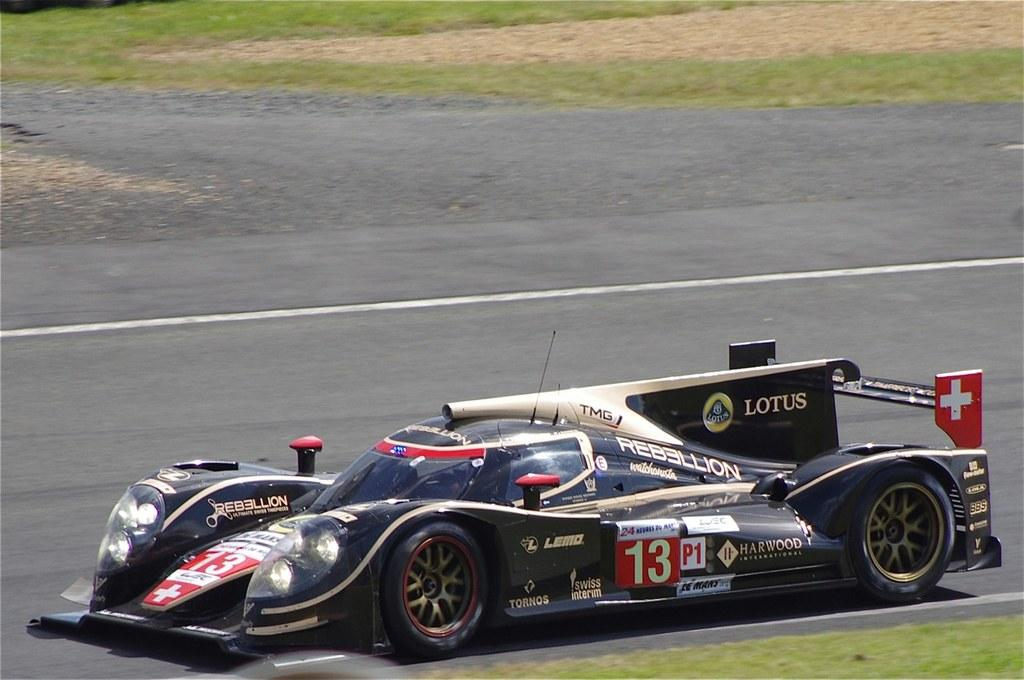What is the main subject of the picture? The main subject of the picture is a car. What can be seen on the car in the image? The car has different stickers on it. What feature of the car is visible in the image? The car has headlights. What type of natural environment is visible in the image? There is grass at the top and bottom of the image. What type of creature is depicted on the plate in the image? There is no plate present in the image, so no creature can be observed on a plate. 